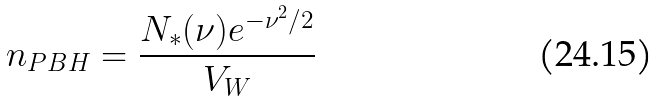Convert formula to latex. <formula><loc_0><loc_0><loc_500><loc_500>n _ { P B H } = \frac { N _ { * } ( \nu ) e ^ { - \nu ^ { 2 } / 2 } } { V _ { W } }</formula> 